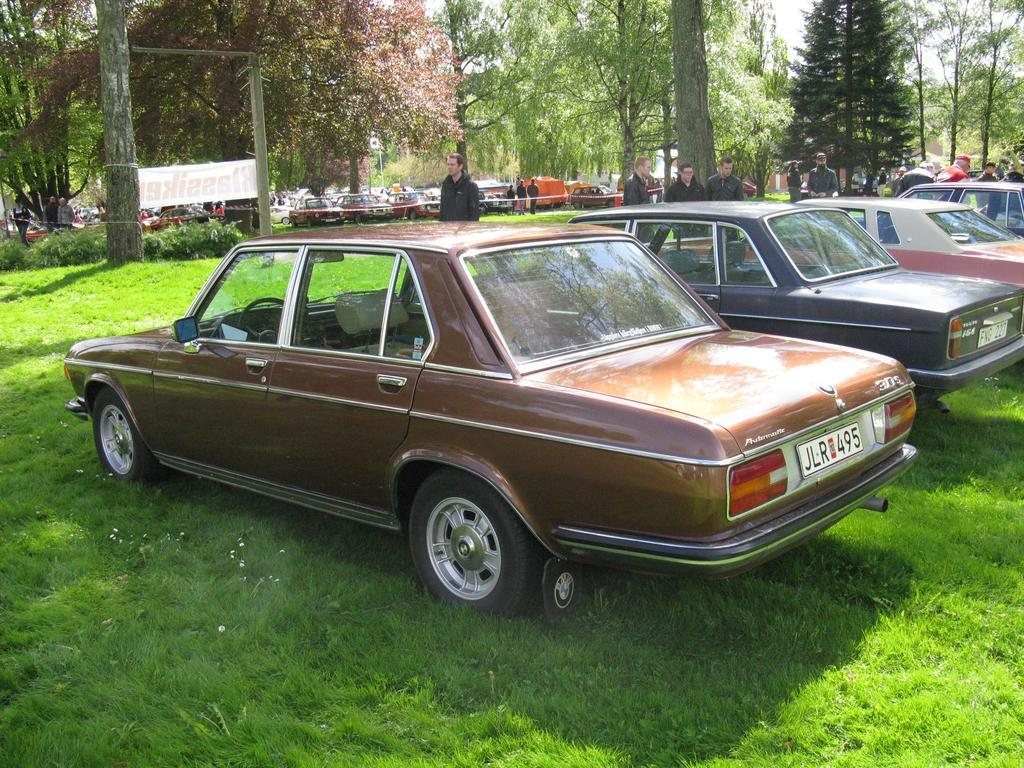What can be seen in the image in terms of vehicles? There are many cars placed in rows in the image. What can be seen in the background of the image? There are trees, persons, an advertisement, a pole, the sky, and grass in the background of the image. What type of bait is being used to catch fish in the image? There is no bait or fishing activity present in the image. What type of suit is the person in the image wearing? There are no persons wearing suits in the image. 